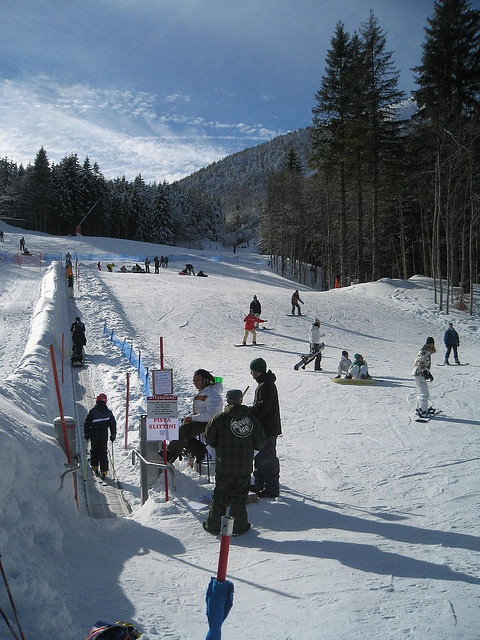Describe the objects in this image and their specific colors. I can see people in gray, black, darkgray, and purple tones, people in gray, black, lightgray, and darkgray tones, people in gray, black, and maroon tones, people in gray, black, darkgray, and maroon tones, and people in gray, black, and darkgray tones in this image. 